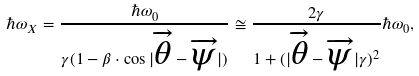Convert formula to latex. <formula><loc_0><loc_0><loc_500><loc_500>\hbar { \omega } _ { X } = \frac { \hbar { \omega } _ { 0 } } { \gamma ( 1 - \beta \cdot \cos | \overrightarrow { \theta } - \overrightarrow { \psi } | ) } \cong \frac { 2 \gamma } { 1 + ( | \overrightarrow { \theta } - \overrightarrow { \psi } | \gamma ) ^ { 2 } } \hbar { \omega } _ { 0 } ,</formula> 